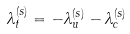Convert formula to latex. <formula><loc_0><loc_0><loc_500><loc_500>\lambda _ { t } ^ { ( s ) } = - \lambda _ { u } ^ { ( s ) } - \lambda _ { c } ^ { ( s ) }</formula> 